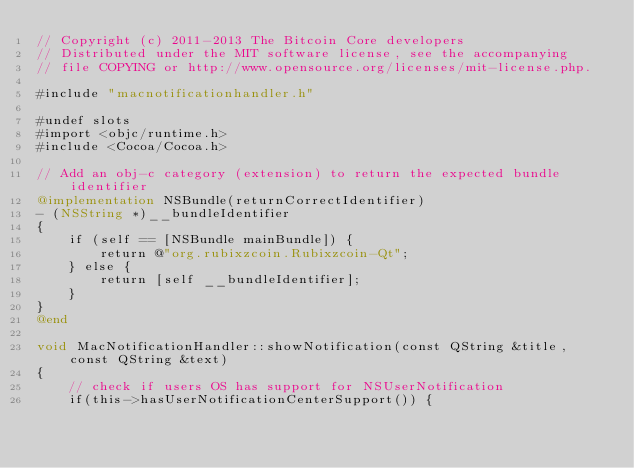<code> <loc_0><loc_0><loc_500><loc_500><_ObjectiveC_>// Copyright (c) 2011-2013 The Bitcoin Core developers
// Distributed under the MIT software license, see the accompanying
// file COPYING or http://www.opensource.org/licenses/mit-license.php.

#include "macnotificationhandler.h"

#undef slots
#import <objc/runtime.h>
#include <Cocoa/Cocoa.h>

// Add an obj-c category (extension) to return the expected bundle identifier
@implementation NSBundle(returnCorrectIdentifier)
- (NSString *)__bundleIdentifier
{
    if (self == [NSBundle mainBundle]) {
        return @"org.rubixzcoin.Rubixzcoin-Qt";
    } else {
        return [self __bundleIdentifier];
    }
}
@end

void MacNotificationHandler::showNotification(const QString &title, const QString &text)
{
    // check if users OS has support for NSUserNotification
    if(this->hasUserNotificationCenterSupport()) {</code> 